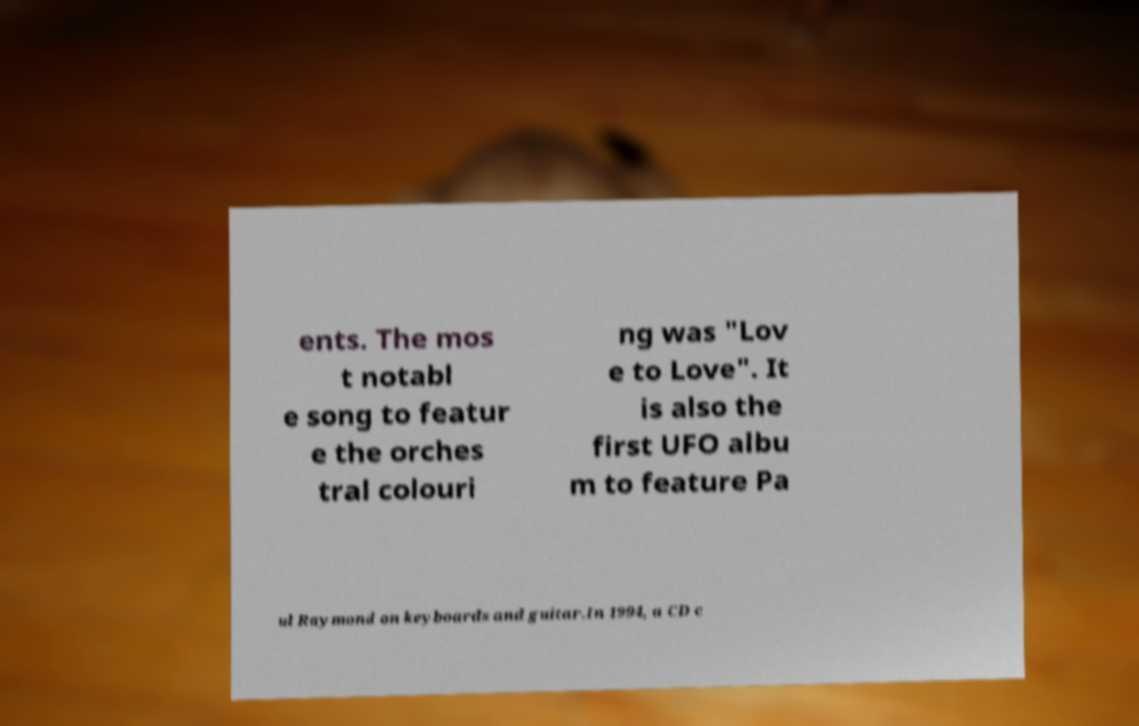Please identify and transcribe the text found in this image. ents. The mos t notabl e song to featur e the orches tral colouri ng was "Lov e to Love". It is also the first UFO albu m to feature Pa ul Raymond on keyboards and guitar.In 1994, a CD c 